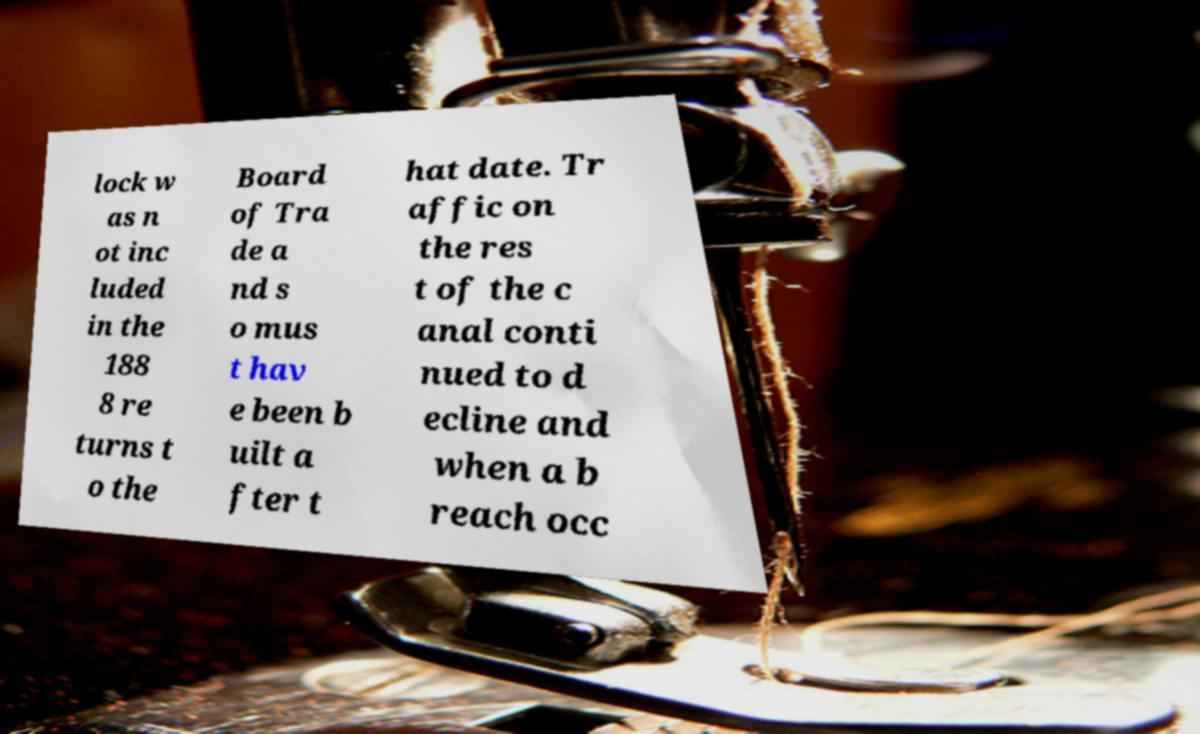Please identify and transcribe the text found in this image. lock w as n ot inc luded in the 188 8 re turns t o the Board of Tra de a nd s o mus t hav e been b uilt a fter t hat date. Tr affic on the res t of the c anal conti nued to d ecline and when a b reach occ 